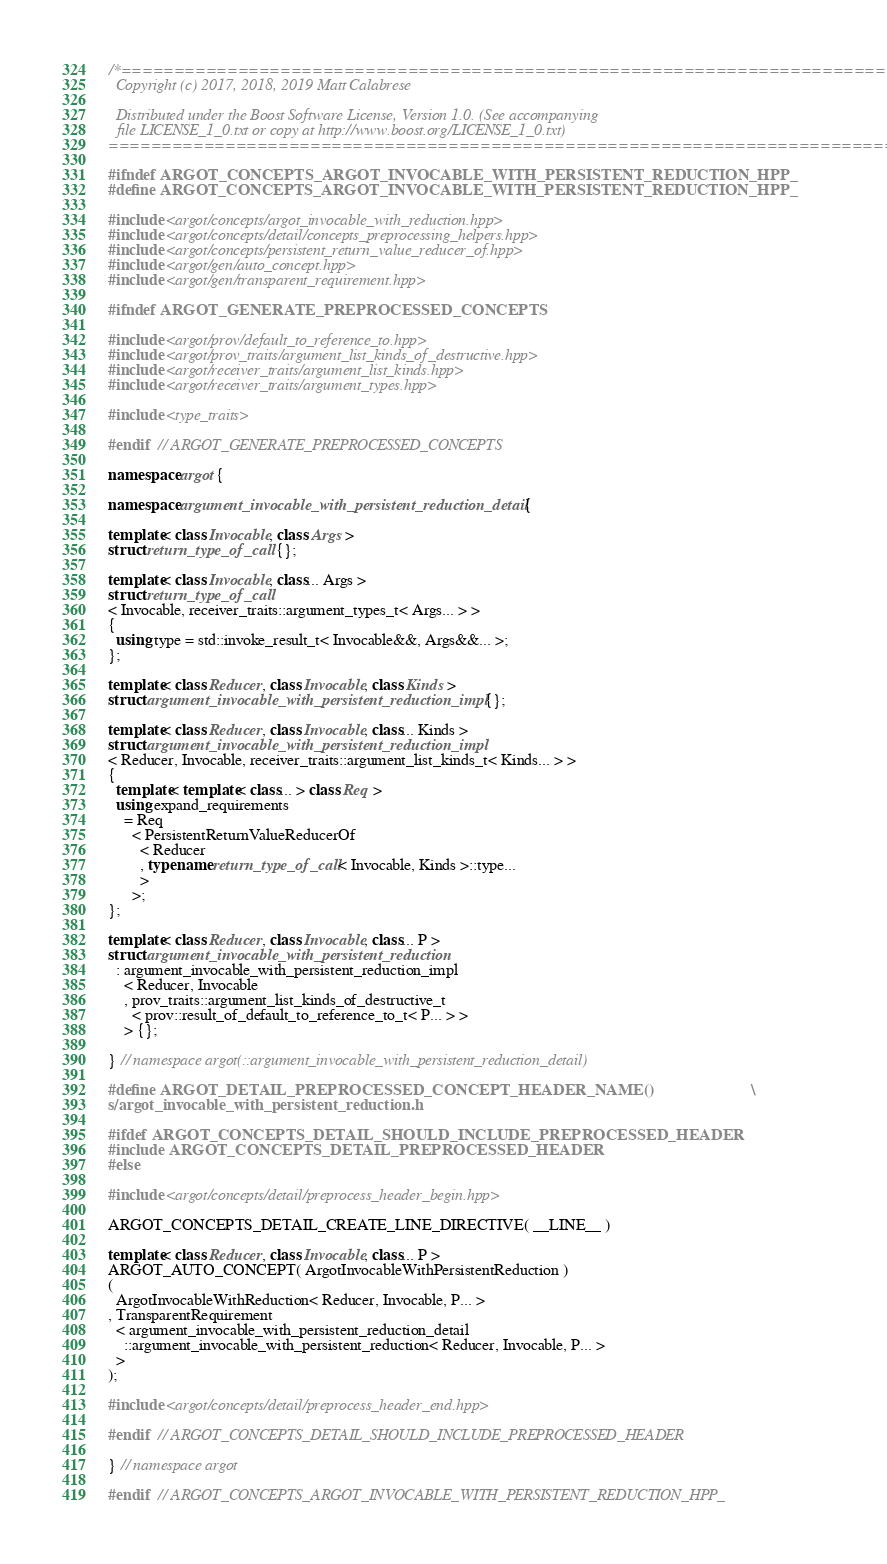Convert code to text. <code><loc_0><loc_0><loc_500><loc_500><_C++_>/*==============================================================================
  Copyright (c) 2017, 2018, 2019 Matt Calabrese

  Distributed under the Boost Software License, Version 1.0. (See accompanying
  file LICENSE_1_0.txt or copy at http://www.boost.org/LICENSE_1_0.txt)
==============================================================================*/

#ifndef ARGOT_CONCEPTS_ARGOT_INVOCABLE_WITH_PERSISTENT_REDUCTION_HPP_
#define ARGOT_CONCEPTS_ARGOT_INVOCABLE_WITH_PERSISTENT_REDUCTION_HPP_

#include <argot/concepts/argot_invocable_with_reduction.hpp>
#include <argot/concepts/detail/concepts_preprocessing_helpers.hpp>
#include <argot/concepts/persistent_return_value_reducer_of.hpp>
#include <argot/gen/auto_concept.hpp>
#include <argot/gen/transparent_requirement.hpp>

#ifndef ARGOT_GENERATE_PREPROCESSED_CONCEPTS

#include <argot/prov/default_to_reference_to.hpp>
#include <argot/prov_traits/argument_list_kinds_of_destructive.hpp>
#include <argot/receiver_traits/argument_list_kinds.hpp>
#include <argot/receiver_traits/argument_types.hpp>

#include <type_traits>

#endif  // ARGOT_GENERATE_PREPROCESSED_CONCEPTS

namespace argot {

namespace argument_invocable_with_persistent_reduction_detail {

template< class Invocable, class Args >
struct return_type_of_call {};

template< class Invocable, class... Args >
struct return_type_of_call
< Invocable, receiver_traits::argument_types_t< Args... > >
{
  using type = std::invoke_result_t< Invocable&&, Args&&... >;
};

template< class Reducer, class Invocable, class Kinds >
struct argument_invocable_with_persistent_reduction_impl {};

template< class Reducer, class Invocable, class... Kinds >
struct argument_invocable_with_persistent_reduction_impl
< Reducer, Invocable, receiver_traits::argument_list_kinds_t< Kinds... > >
{
  template< template< class... > class Req >
  using expand_requirements
    = Req
      < PersistentReturnValueReducerOf
        < Reducer
        , typename return_type_of_call< Invocable, Kinds >::type...
        >
      >;
};

template< class Reducer, class Invocable, class... P >
struct argument_invocable_with_persistent_reduction
  : argument_invocable_with_persistent_reduction_impl
    < Reducer, Invocable
    , prov_traits::argument_list_kinds_of_destructive_t
      < prov::result_of_default_to_reference_to_t< P... > >
    > {};

} // namespace argot(::argument_invocable_with_persistent_reduction_detail)

#define ARGOT_DETAIL_PREPROCESSED_CONCEPT_HEADER_NAME()                        \
s/argot_invocable_with_persistent_reduction.h

#ifdef ARGOT_CONCEPTS_DETAIL_SHOULD_INCLUDE_PREPROCESSED_HEADER
#include ARGOT_CONCEPTS_DETAIL_PREPROCESSED_HEADER
#else

#include <argot/concepts/detail/preprocess_header_begin.hpp>

ARGOT_CONCEPTS_DETAIL_CREATE_LINE_DIRECTIVE( __LINE__ )

template< class Reducer, class Invocable, class... P >
ARGOT_AUTO_CONCEPT( ArgotInvocableWithPersistentReduction )
(
  ArgotInvocableWithReduction< Reducer, Invocable, P... >
, TransparentRequirement
  < argument_invocable_with_persistent_reduction_detail
    ::argument_invocable_with_persistent_reduction< Reducer, Invocable, P... >
  >
);

#include <argot/concepts/detail/preprocess_header_end.hpp>

#endif  // ARGOT_CONCEPTS_DETAIL_SHOULD_INCLUDE_PREPROCESSED_HEADER

} // namespace argot

#endif  // ARGOT_CONCEPTS_ARGOT_INVOCABLE_WITH_PERSISTENT_REDUCTION_HPP_
</code> 